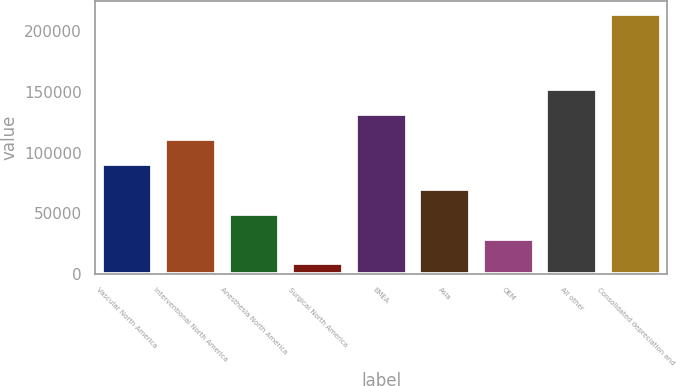Convert chart. <chart><loc_0><loc_0><loc_500><loc_500><bar_chart><fcel>Vascular North America<fcel>Interventional North America<fcel>Anesthesia North America<fcel>Surgical North America<fcel>EMEA<fcel>Asia<fcel>OEM<fcel>All other<fcel>Consolidated depreciation and<nl><fcel>90878.2<fcel>111518<fcel>49599.6<fcel>8321<fcel>132157<fcel>70238.9<fcel>28960.3<fcel>152796<fcel>214714<nl></chart> 